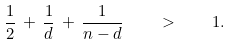Convert formula to latex. <formula><loc_0><loc_0><loc_500><loc_500>\frac { 1 } { 2 } \, + \, \frac { 1 } { d } \, + \, \frac { 1 } { n - d } \quad > \quad 1 .</formula> 